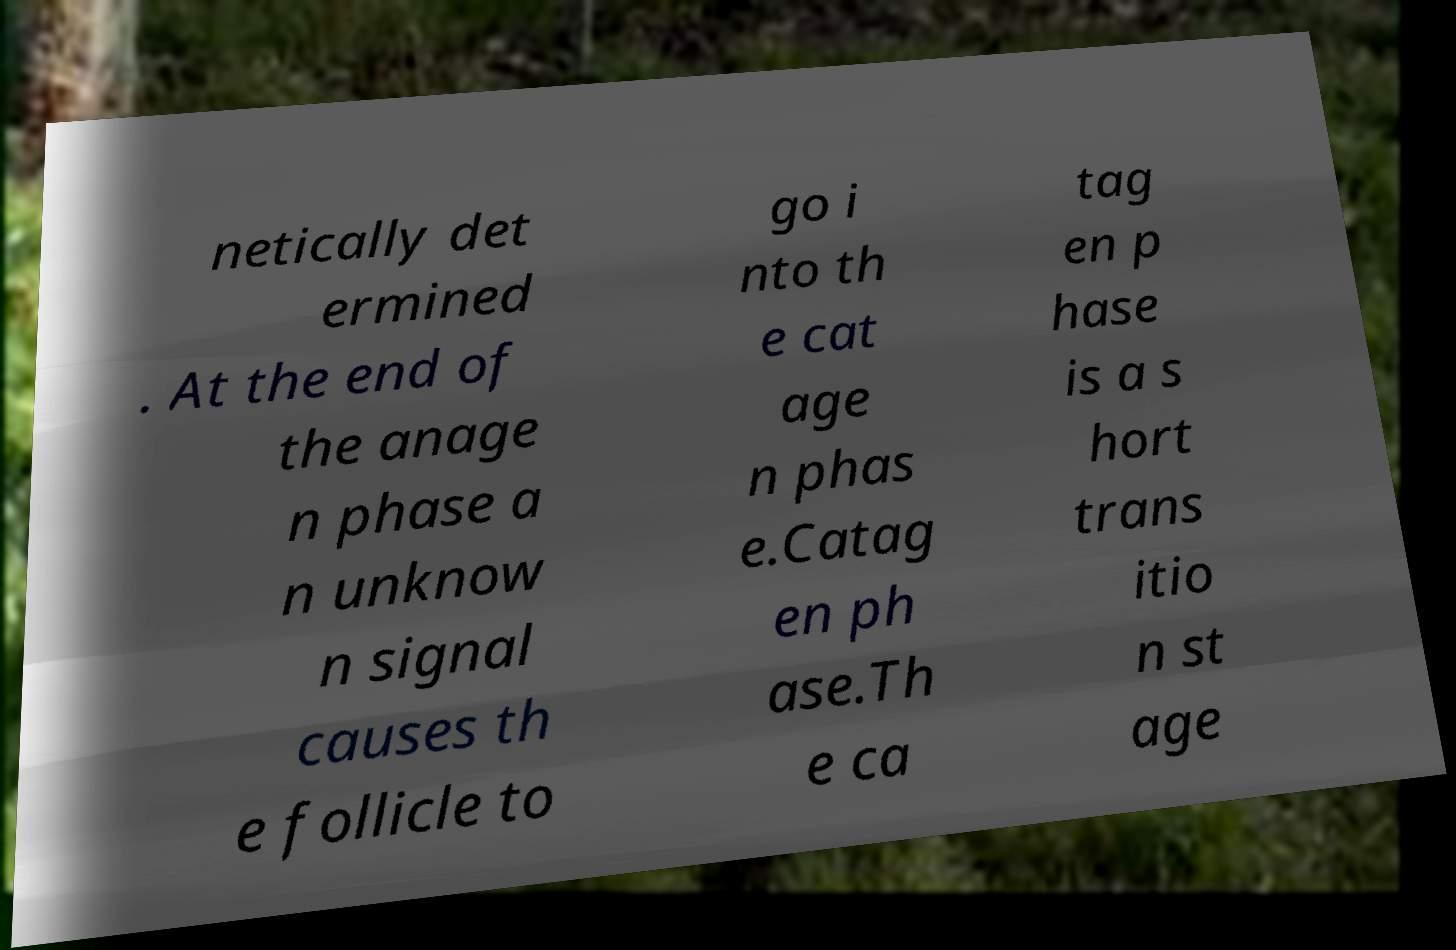Please read and relay the text visible in this image. What does it say? netically det ermined . At the end of the anage n phase a n unknow n signal causes th e follicle to go i nto th e cat age n phas e.Catag en ph ase.Th e ca tag en p hase is a s hort trans itio n st age 